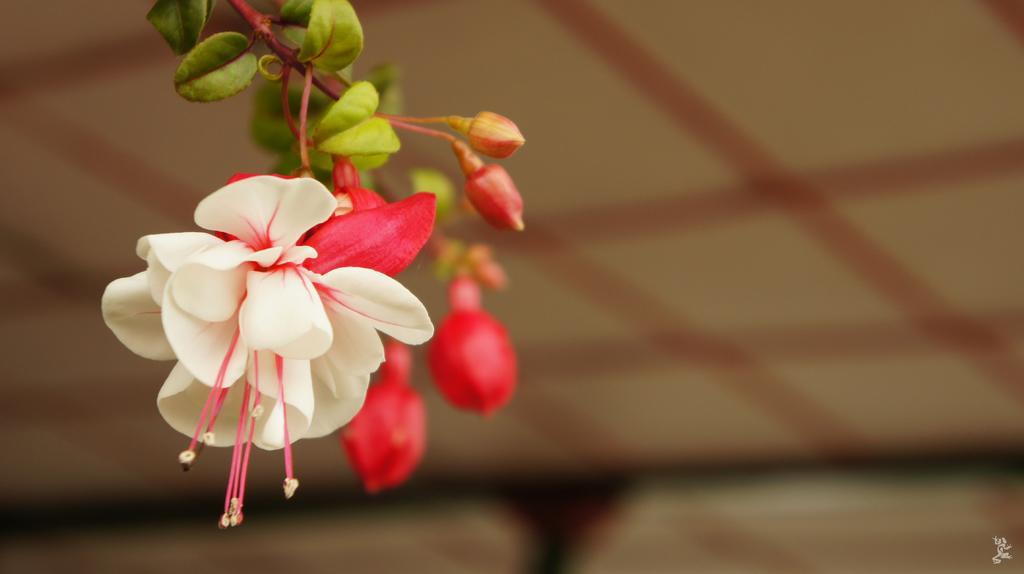How would you summarize this image in a sentence or two? In this image there are flowers and buds with leaves and in the background it is blurred. 